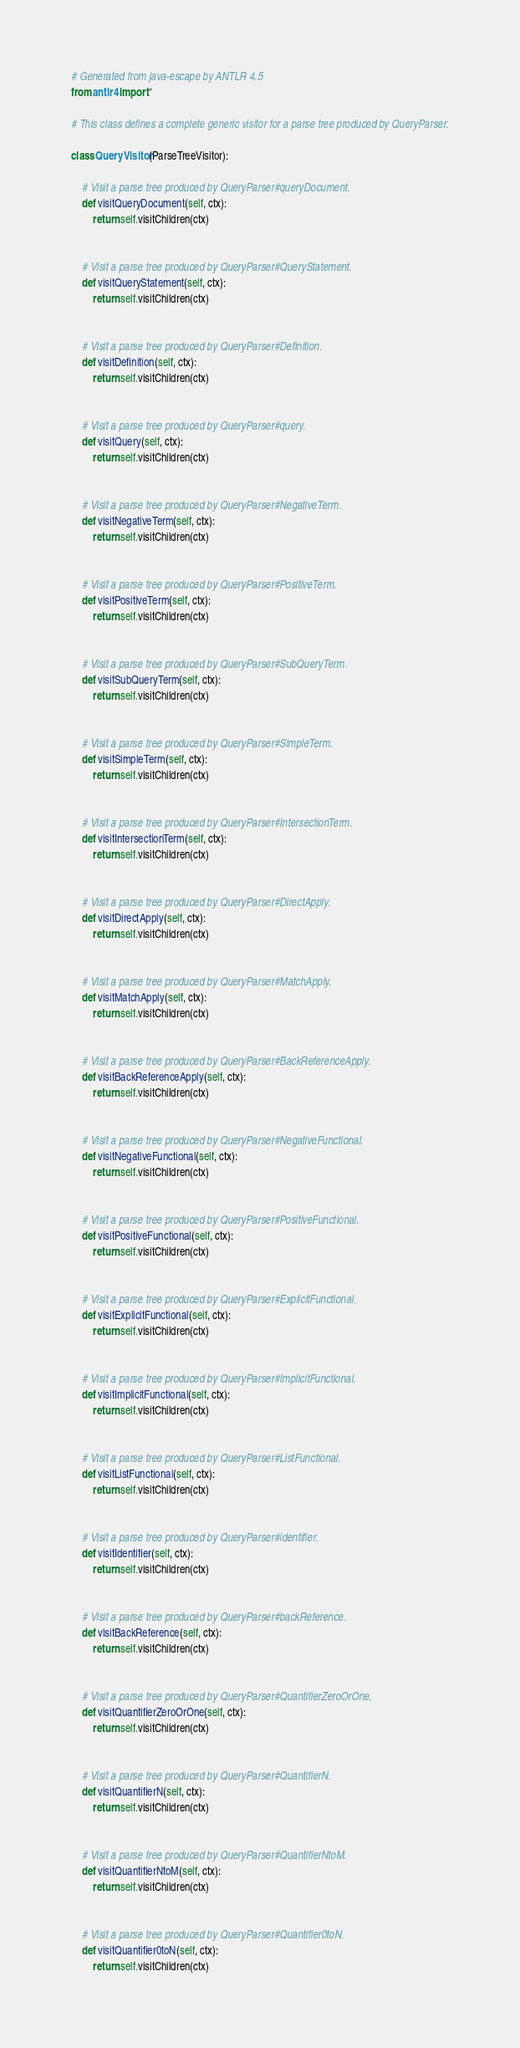<code> <loc_0><loc_0><loc_500><loc_500><_Python_># Generated from java-escape by ANTLR 4.5
from antlr4 import *

# This class defines a complete generic visitor for a parse tree produced by QueryParser.

class QueryVisitor(ParseTreeVisitor):

    # Visit a parse tree produced by QueryParser#queryDocument.
    def visitQueryDocument(self, ctx):
        return self.visitChildren(ctx)


    # Visit a parse tree produced by QueryParser#QueryStatement.
    def visitQueryStatement(self, ctx):
        return self.visitChildren(ctx)


    # Visit a parse tree produced by QueryParser#Definition.
    def visitDefinition(self, ctx):
        return self.visitChildren(ctx)


    # Visit a parse tree produced by QueryParser#query.
    def visitQuery(self, ctx):
        return self.visitChildren(ctx)


    # Visit a parse tree produced by QueryParser#NegativeTerm.
    def visitNegativeTerm(self, ctx):
        return self.visitChildren(ctx)


    # Visit a parse tree produced by QueryParser#PositiveTerm.
    def visitPositiveTerm(self, ctx):
        return self.visitChildren(ctx)


    # Visit a parse tree produced by QueryParser#SubQueryTerm.
    def visitSubQueryTerm(self, ctx):
        return self.visitChildren(ctx)


    # Visit a parse tree produced by QueryParser#SimpleTerm.
    def visitSimpleTerm(self, ctx):
        return self.visitChildren(ctx)


    # Visit a parse tree produced by QueryParser#IntersectionTerm.
    def visitIntersectionTerm(self, ctx):
        return self.visitChildren(ctx)


    # Visit a parse tree produced by QueryParser#DirectApply.
    def visitDirectApply(self, ctx):
        return self.visitChildren(ctx)


    # Visit a parse tree produced by QueryParser#MatchApply.
    def visitMatchApply(self, ctx):
        return self.visitChildren(ctx)


    # Visit a parse tree produced by QueryParser#BackReferenceApply.
    def visitBackReferenceApply(self, ctx):
        return self.visitChildren(ctx)


    # Visit a parse tree produced by QueryParser#NegativeFunctional.
    def visitNegativeFunctional(self, ctx):
        return self.visitChildren(ctx)


    # Visit a parse tree produced by QueryParser#PositiveFunctional.
    def visitPositiveFunctional(self, ctx):
        return self.visitChildren(ctx)


    # Visit a parse tree produced by QueryParser#ExplicitFunctional.
    def visitExplicitFunctional(self, ctx):
        return self.visitChildren(ctx)


    # Visit a parse tree produced by QueryParser#ImplicitFunctional.
    def visitImplicitFunctional(self, ctx):
        return self.visitChildren(ctx)


    # Visit a parse tree produced by QueryParser#ListFunctional.
    def visitListFunctional(self, ctx):
        return self.visitChildren(ctx)


    # Visit a parse tree produced by QueryParser#identifier.
    def visitIdentifier(self, ctx):
        return self.visitChildren(ctx)


    # Visit a parse tree produced by QueryParser#backReference.
    def visitBackReference(self, ctx):
        return self.visitChildren(ctx)


    # Visit a parse tree produced by QueryParser#QuantifierZeroOrOne.
    def visitQuantifierZeroOrOne(self, ctx):
        return self.visitChildren(ctx)


    # Visit a parse tree produced by QueryParser#QuantifierN.
    def visitQuantifierN(self, ctx):
        return self.visitChildren(ctx)


    # Visit a parse tree produced by QueryParser#QuantifierNtoM.
    def visitQuantifierNtoM(self, ctx):
        return self.visitChildren(ctx)


    # Visit a parse tree produced by QueryParser#Quantifier0toN.
    def visitQuantifier0toN(self, ctx):
        return self.visitChildren(ctx)

</code> 